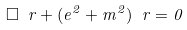Convert formula to latex. <formula><loc_0><loc_0><loc_500><loc_500>\square \ r + ( e ^ { 2 } + m ^ { 2 } ) \ r = 0</formula> 